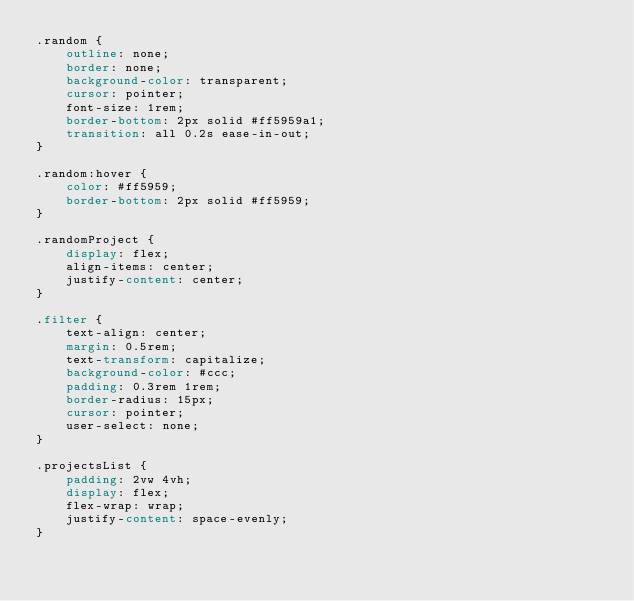<code> <loc_0><loc_0><loc_500><loc_500><_CSS_>.random {
    outline: none;
    border: none;
    background-color: transparent;
    cursor: pointer;
    font-size: 1rem;
    border-bottom: 2px solid #ff5959a1;
    transition: all 0.2s ease-in-out;
}

.random:hover {
    color: #ff5959;
    border-bottom: 2px solid #ff5959;
}

.randomProject {
    display: flex;
    align-items: center;
    justify-content: center;
}

.filter {
    text-align: center;
    margin: 0.5rem;
    text-transform: capitalize;
    background-color: #ccc;
    padding: 0.3rem 1rem;
    border-radius: 15px;
    cursor: pointer;
    user-select: none;
}

.projectsList {
    padding: 2vw 4vh;
    display: flex;
    flex-wrap: wrap;
    justify-content: space-evenly;
}</code> 